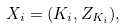Convert formula to latex. <formula><loc_0><loc_0><loc_500><loc_500>X _ { i } & = ( K _ { i } , Z _ { K _ { i } } ) ,</formula> 